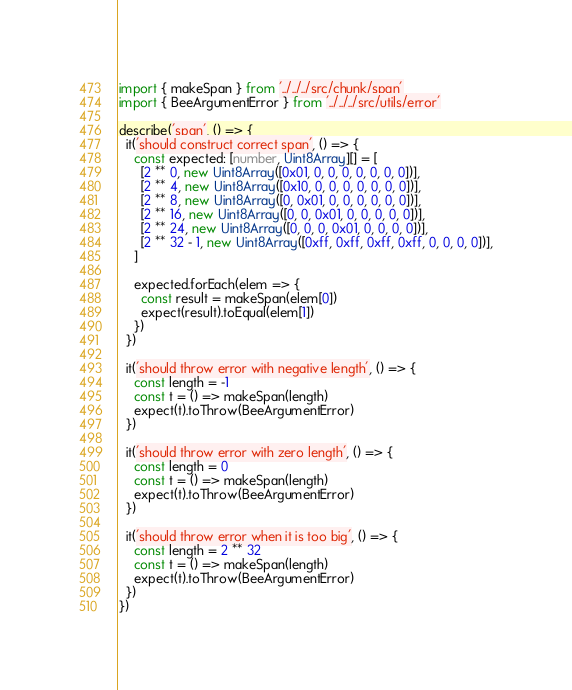Convert code to text. <code><loc_0><loc_0><loc_500><loc_500><_TypeScript_>import { makeSpan } from '../../../src/chunk/span'
import { BeeArgumentError } from '../../../src/utils/error'

describe('span', () => {
  it('should construct correct span', () => {
    const expected: [number, Uint8Array][] = [
      [2 ** 0, new Uint8Array([0x01, 0, 0, 0, 0, 0, 0, 0])],
      [2 ** 4, new Uint8Array([0x10, 0, 0, 0, 0, 0, 0, 0])],
      [2 ** 8, new Uint8Array([0, 0x01, 0, 0, 0, 0, 0, 0])],
      [2 ** 16, new Uint8Array([0, 0, 0x01, 0, 0, 0, 0, 0])],
      [2 ** 24, new Uint8Array([0, 0, 0, 0x01, 0, 0, 0, 0])],
      [2 ** 32 - 1, new Uint8Array([0xff, 0xff, 0xff, 0xff, 0, 0, 0, 0])],
    ]

    expected.forEach(elem => {
      const result = makeSpan(elem[0])
      expect(result).toEqual(elem[1])
    })
  })

  it('should throw error with negative length', () => {
    const length = -1
    const t = () => makeSpan(length)
    expect(t).toThrow(BeeArgumentError)
  })

  it('should throw error with zero length', () => {
    const length = 0
    const t = () => makeSpan(length)
    expect(t).toThrow(BeeArgumentError)
  })

  it('should throw error when it is too big', () => {
    const length = 2 ** 32
    const t = () => makeSpan(length)
    expect(t).toThrow(BeeArgumentError)
  })
})
</code> 